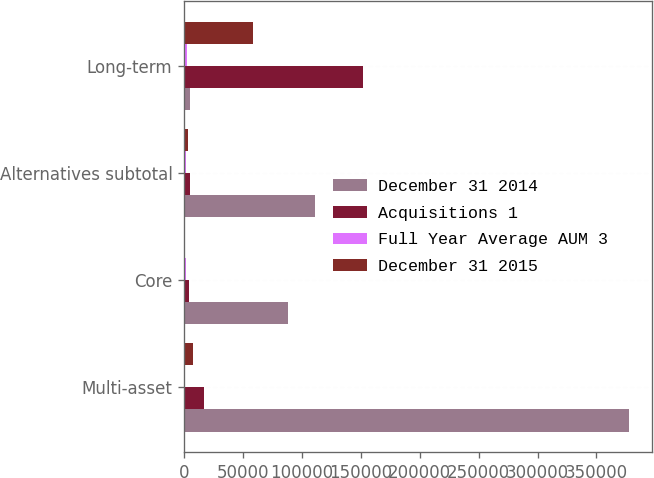<chart> <loc_0><loc_0><loc_500><loc_500><stacked_bar_chart><ecel><fcel>Multi-asset<fcel>Core<fcel>Alternatives subtotal<fcel>Long-term<nl><fcel>December 31 2014<fcel>377837<fcel>88006<fcel>111240<fcel>5125<nl><fcel>Acquisitions 1<fcel>17167<fcel>4080<fcel>5125<fcel>152014<nl><fcel>Full Year Average AUM 3<fcel>366<fcel>1853<fcel>1853<fcel>2219<nl><fcel>December 31 2015<fcel>7413<fcel>213<fcel>3436<fcel>58223<nl></chart> 